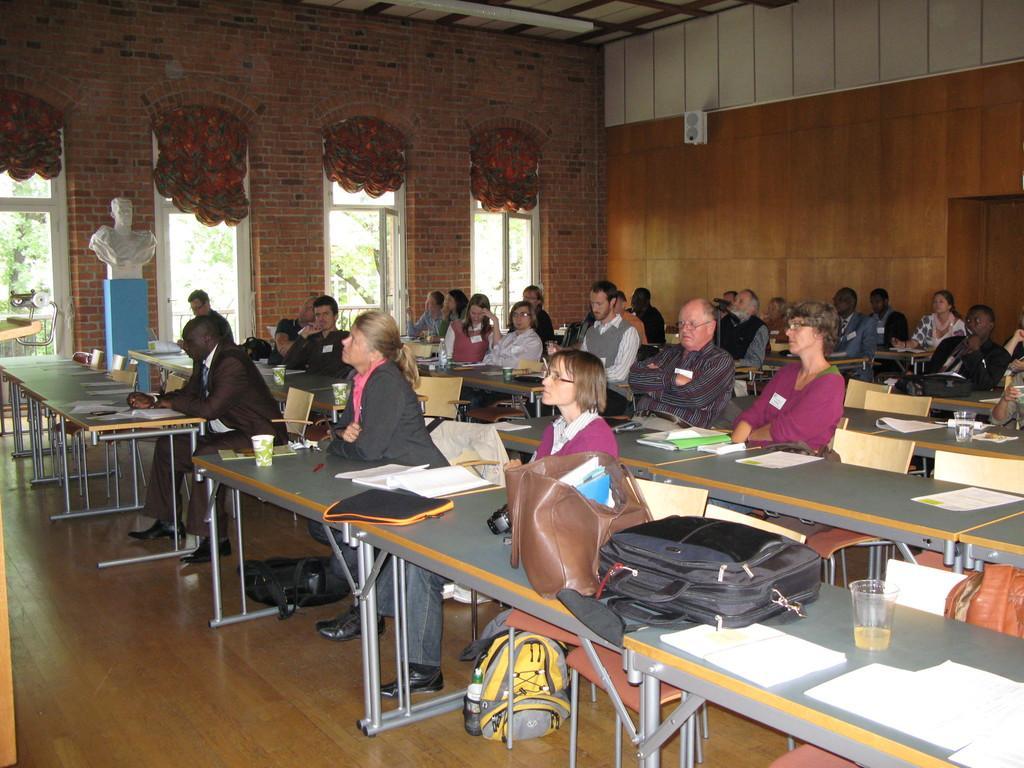Please provide a concise description of this image. In the image few people are sitting on chairs in front of them there are few tables. On the tables there are some papers, books, bags and cups and glasses. Behind them there is a wall and there are some windows. Through the windows we can see some trees. 